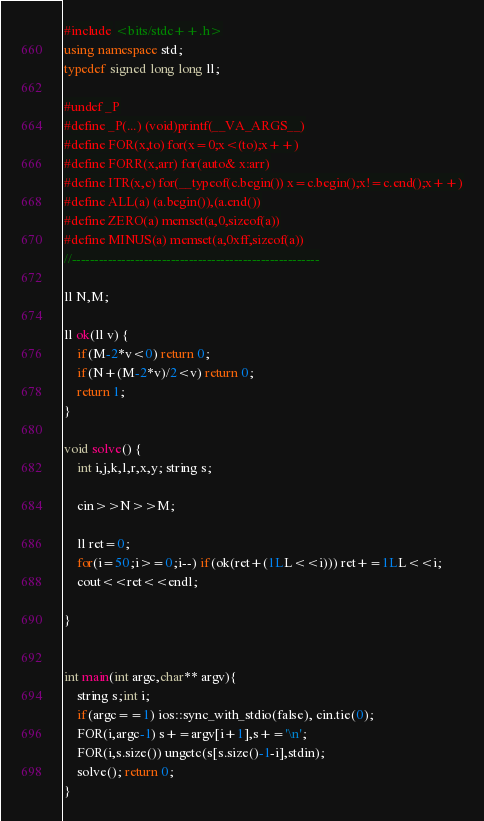Convert code to text. <code><loc_0><loc_0><loc_500><loc_500><_C++_>#include <bits/stdc++.h>
using namespace std;
typedef signed long long ll;

#undef _P
#define _P(...) (void)printf(__VA_ARGS__)
#define FOR(x,to) for(x=0;x<(to);x++)
#define FORR(x,arr) for(auto& x:arr)
#define ITR(x,c) for(__typeof(c.begin()) x=c.begin();x!=c.end();x++)
#define ALL(a) (a.begin()),(a.end())
#define ZERO(a) memset(a,0,sizeof(a))
#define MINUS(a) memset(a,0xff,sizeof(a))
//-------------------------------------------------------

ll N,M;

ll ok(ll v) {
	if(M-2*v<0) return 0;
	if(N+(M-2*v)/2<v) return 0;
	return 1;
}

void solve() {
	int i,j,k,l,r,x,y; string s;
	
	cin>>N>>M;
	
	ll ret=0;
	for(i=50;i>=0;i--) if(ok(ret+(1LL<<i))) ret+=1LL<<i;
	cout<<ret<<endl;
	
}


int main(int argc,char** argv){
	string s;int i;
	if(argc==1) ios::sync_with_stdio(false), cin.tie(0);
	FOR(i,argc-1) s+=argv[i+1],s+='\n';
	FOR(i,s.size()) ungetc(s[s.size()-1-i],stdin);
	solve(); return 0;
}
</code> 